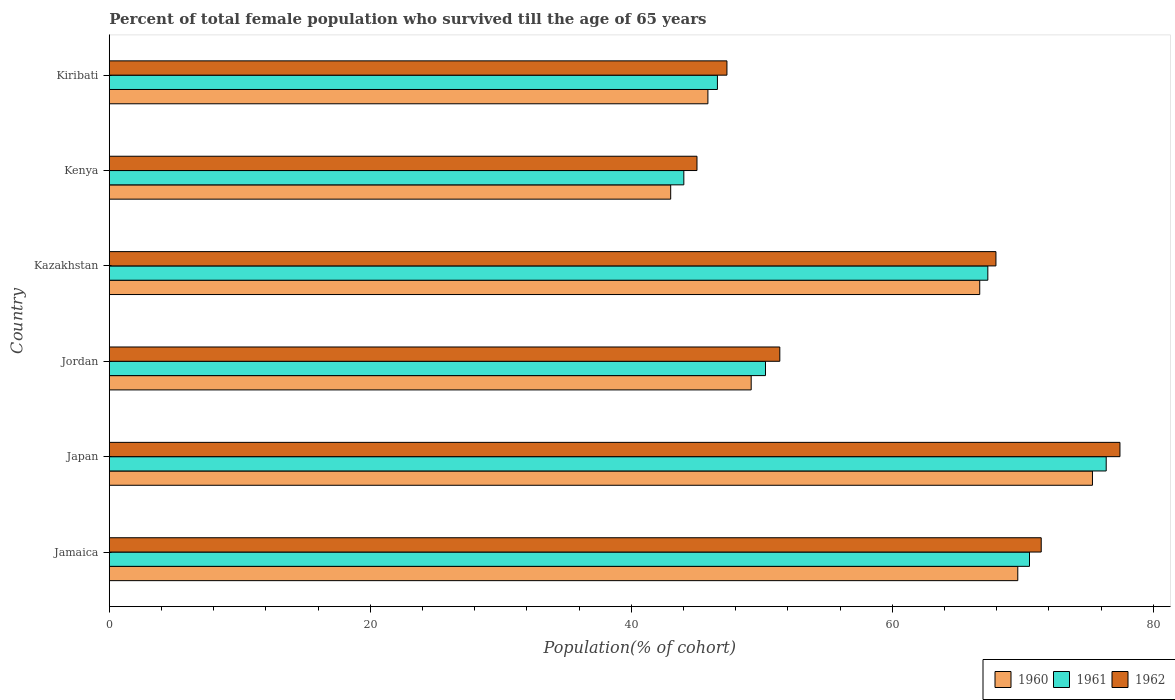How many different coloured bars are there?
Provide a short and direct response. 3. Are the number of bars per tick equal to the number of legend labels?
Your answer should be very brief. Yes. How many bars are there on the 2nd tick from the bottom?
Make the answer very short. 3. What is the percentage of total female population who survived till the age of 65 years in 1961 in Kazakhstan?
Provide a short and direct response. 67.33. Across all countries, what is the maximum percentage of total female population who survived till the age of 65 years in 1961?
Give a very brief answer. 76.4. Across all countries, what is the minimum percentage of total female population who survived till the age of 65 years in 1962?
Your response must be concise. 45.04. In which country was the percentage of total female population who survived till the age of 65 years in 1962 minimum?
Your response must be concise. Kenya. What is the total percentage of total female population who survived till the age of 65 years in 1962 in the graph?
Your answer should be very brief. 360.58. What is the difference between the percentage of total female population who survived till the age of 65 years in 1962 in Jordan and that in Kiribati?
Offer a very short reply. 4.05. What is the difference between the percentage of total female population who survived till the age of 65 years in 1960 in Japan and the percentage of total female population who survived till the age of 65 years in 1961 in Jamaica?
Your response must be concise. 4.82. What is the average percentage of total female population who survived till the age of 65 years in 1961 per country?
Offer a terse response. 59.2. What is the difference between the percentage of total female population who survived till the age of 65 years in 1961 and percentage of total female population who survived till the age of 65 years in 1960 in Japan?
Your response must be concise. 1.05. In how many countries, is the percentage of total female population who survived till the age of 65 years in 1962 greater than 24 %?
Keep it short and to the point. 6. What is the ratio of the percentage of total female population who survived till the age of 65 years in 1962 in Jordan to that in Kiribati?
Keep it short and to the point. 1.09. Is the difference between the percentage of total female population who survived till the age of 65 years in 1961 in Japan and Kiribati greater than the difference between the percentage of total female population who survived till the age of 65 years in 1960 in Japan and Kiribati?
Your answer should be compact. Yes. What is the difference between the highest and the second highest percentage of total female population who survived till the age of 65 years in 1961?
Your response must be concise. 5.88. What is the difference between the highest and the lowest percentage of total female population who survived till the age of 65 years in 1960?
Ensure brevity in your answer.  32.32. Is the sum of the percentage of total female population who survived till the age of 65 years in 1962 in Japan and Kenya greater than the maximum percentage of total female population who survived till the age of 65 years in 1961 across all countries?
Give a very brief answer. Yes. What does the 1st bar from the top in Kazakhstan represents?
Make the answer very short. 1962. What does the 3rd bar from the bottom in Kenya represents?
Offer a terse response. 1962. Is it the case that in every country, the sum of the percentage of total female population who survived till the age of 65 years in 1960 and percentage of total female population who survived till the age of 65 years in 1962 is greater than the percentage of total female population who survived till the age of 65 years in 1961?
Your answer should be compact. Yes. Are all the bars in the graph horizontal?
Offer a very short reply. Yes. How many countries are there in the graph?
Offer a very short reply. 6. Are the values on the major ticks of X-axis written in scientific E-notation?
Provide a succinct answer. No. Does the graph contain grids?
Your answer should be very brief. No. Where does the legend appear in the graph?
Make the answer very short. Bottom right. How many legend labels are there?
Keep it short and to the point. 3. How are the legend labels stacked?
Provide a short and direct response. Horizontal. What is the title of the graph?
Give a very brief answer. Percent of total female population who survived till the age of 65 years. What is the label or title of the X-axis?
Your response must be concise. Population(% of cohort). What is the Population(% of cohort) of 1960 in Jamaica?
Make the answer very short. 69.62. What is the Population(% of cohort) of 1961 in Jamaica?
Offer a terse response. 70.52. What is the Population(% of cohort) in 1962 in Jamaica?
Your answer should be very brief. 71.42. What is the Population(% of cohort) in 1960 in Japan?
Provide a short and direct response. 75.35. What is the Population(% of cohort) in 1961 in Japan?
Your answer should be compact. 76.4. What is the Population(% of cohort) in 1962 in Japan?
Your answer should be very brief. 77.45. What is the Population(% of cohort) in 1960 in Jordan?
Make the answer very short. 49.19. What is the Population(% of cohort) in 1961 in Jordan?
Your response must be concise. 50.29. What is the Population(% of cohort) of 1962 in Jordan?
Your answer should be compact. 51.39. What is the Population(% of cohort) in 1960 in Kazakhstan?
Your response must be concise. 66.71. What is the Population(% of cohort) of 1961 in Kazakhstan?
Offer a very short reply. 67.33. What is the Population(% of cohort) of 1962 in Kazakhstan?
Give a very brief answer. 67.95. What is the Population(% of cohort) of 1960 in Kenya?
Provide a succinct answer. 43.02. What is the Population(% of cohort) of 1961 in Kenya?
Ensure brevity in your answer.  44.03. What is the Population(% of cohort) in 1962 in Kenya?
Your answer should be compact. 45.04. What is the Population(% of cohort) of 1960 in Kiribati?
Your response must be concise. 45.88. What is the Population(% of cohort) in 1961 in Kiribati?
Provide a succinct answer. 46.6. What is the Population(% of cohort) of 1962 in Kiribati?
Your answer should be very brief. 47.33. Across all countries, what is the maximum Population(% of cohort) of 1960?
Ensure brevity in your answer.  75.35. Across all countries, what is the maximum Population(% of cohort) of 1961?
Your answer should be compact. 76.4. Across all countries, what is the maximum Population(% of cohort) in 1962?
Your response must be concise. 77.45. Across all countries, what is the minimum Population(% of cohort) in 1960?
Your answer should be very brief. 43.02. Across all countries, what is the minimum Population(% of cohort) of 1961?
Give a very brief answer. 44.03. Across all countries, what is the minimum Population(% of cohort) of 1962?
Provide a short and direct response. 45.04. What is the total Population(% of cohort) of 1960 in the graph?
Provide a succinct answer. 349.77. What is the total Population(% of cohort) in 1961 in the graph?
Provide a succinct answer. 355.17. What is the total Population(% of cohort) of 1962 in the graph?
Keep it short and to the point. 360.58. What is the difference between the Population(% of cohort) of 1960 in Jamaica and that in Japan?
Offer a terse response. -5.72. What is the difference between the Population(% of cohort) in 1961 in Jamaica and that in Japan?
Give a very brief answer. -5.88. What is the difference between the Population(% of cohort) in 1962 in Jamaica and that in Japan?
Your answer should be very brief. -6.03. What is the difference between the Population(% of cohort) in 1960 in Jamaica and that in Jordan?
Ensure brevity in your answer.  20.43. What is the difference between the Population(% of cohort) in 1961 in Jamaica and that in Jordan?
Offer a terse response. 20.23. What is the difference between the Population(% of cohort) in 1962 in Jamaica and that in Jordan?
Your answer should be compact. 20.03. What is the difference between the Population(% of cohort) in 1960 in Jamaica and that in Kazakhstan?
Your answer should be very brief. 2.92. What is the difference between the Population(% of cohort) in 1961 in Jamaica and that in Kazakhstan?
Offer a terse response. 3.19. What is the difference between the Population(% of cohort) of 1962 in Jamaica and that in Kazakhstan?
Offer a terse response. 3.47. What is the difference between the Population(% of cohort) of 1960 in Jamaica and that in Kenya?
Your answer should be compact. 26.6. What is the difference between the Population(% of cohort) in 1961 in Jamaica and that in Kenya?
Your answer should be compact. 26.49. What is the difference between the Population(% of cohort) of 1962 in Jamaica and that in Kenya?
Your answer should be very brief. 26.38. What is the difference between the Population(% of cohort) of 1960 in Jamaica and that in Kiribati?
Keep it short and to the point. 23.75. What is the difference between the Population(% of cohort) of 1961 in Jamaica and that in Kiribati?
Keep it short and to the point. 23.92. What is the difference between the Population(% of cohort) in 1962 in Jamaica and that in Kiribati?
Your answer should be very brief. 24.08. What is the difference between the Population(% of cohort) in 1960 in Japan and that in Jordan?
Provide a short and direct response. 26.15. What is the difference between the Population(% of cohort) of 1961 in Japan and that in Jordan?
Your answer should be compact. 26.11. What is the difference between the Population(% of cohort) in 1962 in Japan and that in Jordan?
Your response must be concise. 26.07. What is the difference between the Population(% of cohort) of 1960 in Japan and that in Kazakhstan?
Your answer should be very brief. 8.64. What is the difference between the Population(% of cohort) in 1961 in Japan and that in Kazakhstan?
Your answer should be compact. 9.07. What is the difference between the Population(% of cohort) in 1962 in Japan and that in Kazakhstan?
Provide a succinct answer. 9.5. What is the difference between the Population(% of cohort) of 1960 in Japan and that in Kenya?
Your answer should be compact. 32.32. What is the difference between the Population(% of cohort) in 1961 in Japan and that in Kenya?
Your answer should be compact. 32.37. What is the difference between the Population(% of cohort) of 1962 in Japan and that in Kenya?
Your response must be concise. 32.41. What is the difference between the Population(% of cohort) of 1960 in Japan and that in Kiribati?
Your answer should be compact. 29.47. What is the difference between the Population(% of cohort) of 1961 in Japan and that in Kiribati?
Your answer should be very brief. 29.79. What is the difference between the Population(% of cohort) of 1962 in Japan and that in Kiribati?
Make the answer very short. 30.12. What is the difference between the Population(% of cohort) of 1960 in Jordan and that in Kazakhstan?
Keep it short and to the point. -17.51. What is the difference between the Population(% of cohort) of 1961 in Jordan and that in Kazakhstan?
Make the answer very short. -17.04. What is the difference between the Population(% of cohort) of 1962 in Jordan and that in Kazakhstan?
Provide a succinct answer. -16.56. What is the difference between the Population(% of cohort) in 1960 in Jordan and that in Kenya?
Keep it short and to the point. 6.17. What is the difference between the Population(% of cohort) in 1961 in Jordan and that in Kenya?
Your answer should be compact. 6.26. What is the difference between the Population(% of cohort) in 1962 in Jordan and that in Kenya?
Your answer should be compact. 6.35. What is the difference between the Population(% of cohort) in 1960 in Jordan and that in Kiribati?
Make the answer very short. 3.32. What is the difference between the Population(% of cohort) of 1961 in Jordan and that in Kiribati?
Provide a succinct answer. 3.68. What is the difference between the Population(% of cohort) in 1962 in Jordan and that in Kiribati?
Your response must be concise. 4.05. What is the difference between the Population(% of cohort) of 1960 in Kazakhstan and that in Kenya?
Provide a succinct answer. 23.68. What is the difference between the Population(% of cohort) of 1961 in Kazakhstan and that in Kenya?
Your answer should be very brief. 23.3. What is the difference between the Population(% of cohort) in 1962 in Kazakhstan and that in Kenya?
Make the answer very short. 22.91. What is the difference between the Population(% of cohort) in 1960 in Kazakhstan and that in Kiribati?
Ensure brevity in your answer.  20.83. What is the difference between the Population(% of cohort) in 1961 in Kazakhstan and that in Kiribati?
Your answer should be very brief. 20.72. What is the difference between the Population(% of cohort) of 1962 in Kazakhstan and that in Kiribati?
Your response must be concise. 20.61. What is the difference between the Population(% of cohort) in 1960 in Kenya and that in Kiribati?
Offer a terse response. -2.85. What is the difference between the Population(% of cohort) of 1961 in Kenya and that in Kiribati?
Offer a very short reply. -2.57. What is the difference between the Population(% of cohort) in 1962 in Kenya and that in Kiribati?
Provide a succinct answer. -2.3. What is the difference between the Population(% of cohort) in 1960 in Jamaica and the Population(% of cohort) in 1961 in Japan?
Give a very brief answer. -6.78. What is the difference between the Population(% of cohort) of 1960 in Jamaica and the Population(% of cohort) of 1962 in Japan?
Offer a terse response. -7.83. What is the difference between the Population(% of cohort) in 1961 in Jamaica and the Population(% of cohort) in 1962 in Japan?
Ensure brevity in your answer.  -6.93. What is the difference between the Population(% of cohort) of 1960 in Jamaica and the Population(% of cohort) of 1961 in Jordan?
Provide a short and direct response. 19.33. What is the difference between the Population(% of cohort) in 1960 in Jamaica and the Population(% of cohort) in 1962 in Jordan?
Provide a short and direct response. 18.24. What is the difference between the Population(% of cohort) in 1961 in Jamaica and the Population(% of cohort) in 1962 in Jordan?
Make the answer very short. 19.13. What is the difference between the Population(% of cohort) of 1960 in Jamaica and the Population(% of cohort) of 1961 in Kazakhstan?
Offer a very short reply. 2.3. What is the difference between the Population(% of cohort) in 1960 in Jamaica and the Population(% of cohort) in 1962 in Kazakhstan?
Ensure brevity in your answer.  1.67. What is the difference between the Population(% of cohort) of 1961 in Jamaica and the Population(% of cohort) of 1962 in Kazakhstan?
Provide a short and direct response. 2.57. What is the difference between the Population(% of cohort) of 1960 in Jamaica and the Population(% of cohort) of 1961 in Kenya?
Ensure brevity in your answer.  25.59. What is the difference between the Population(% of cohort) in 1960 in Jamaica and the Population(% of cohort) in 1962 in Kenya?
Your response must be concise. 24.58. What is the difference between the Population(% of cohort) of 1961 in Jamaica and the Population(% of cohort) of 1962 in Kenya?
Offer a terse response. 25.48. What is the difference between the Population(% of cohort) of 1960 in Jamaica and the Population(% of cohort) of 1961 in Kiribati?
Ensure brevity in your answer.  23.02. What is the difference between the Population(% of cohort) in 1960 in Jamaica and the Population(% of cohort) in 1962 in Kiribati?
Give a very brief answer. 22.29. What is the difference between the Population(% of cohort) in 1961 in Jamaica and the Population(% of cohort) in 1962 in Kiribati?
Give a very brief answer. 23.19. What is the difference between the Population(% of cohort) of 1960 in Japan and the Population(% of cohort) of 1961 in Jordan?
Your answer should be compact. 25.06. What is the difference between the Population(% of cohort) in 1960 in Japan and the Population(% of cohort) in 1962 in Jordan?
Offer a terse response. 23.96. What is the difference between the Population(% of cohort) in 1961 in Japan and the Population(% of cohort) in 1962 in Jordan?
Offer a terse response. 25.01. What is the difference between the Population(% of cohort) of 1960 in Japan and the Population(% of cohort) of 1961 in Kazakhstan?
Make the answer very short. 8.02. What is the difference between the Population(% of cohort) of 1960 in Japan and the Population(% of cohort) of 1962 in Kazakhstan?
Make the answer very short. 7.4. What is the difference between the Population(% of cohort) of 1961 in Japan and the Population(% of cohort) of 1962 in Kazakhstan?
Offer a very short reply. 8.45. What is the difference between the Population(% of cohort) of 1960 in Japan and the Population(% of cohort) of 1961 in Kenya?
Offer a terse response. 31.31. What is the difference between the Population(% of cohort) of 1960 in Japan and the Population(% of cohort) of 1962 in Kenya?
Give a very brief answer. 30.31. What is the difference between the Population(% of cohort) in 1961 in Japan and the Population(% of cohort) in 1962 in Kenya?
Offer a terse response. 31.36. What is the difference between the Population(% of cohort) in 1960 in Japan and the Population(% of cohort) in 1961 in Kiribati?
Provide a succinct answer. 28.74. What is the difference between the Population(% of cohort) of 1960 in Japan and the Population(% of cohort) of 1962 in Kiribati?
Your response must be concise. 28.01. What is the difference between the Population(% of cohort) of 1961 in Japan and the Population(% of cohort) of 1962 in Kiribati?
Your response must be concise. 29.07. What is the difference between the Population(% of cohort) in 1960 in Jordan and the Population(% of cohort) in 1961 in Kazakhstan?
Offer a very short reply. -18.14. What is the difference between the Population(% of cohort) in 1960 in Jordan and the Population(% of cohort) in 1962 in Kazakhstan?
Give a very brief answer. -18.76. What is the difference between the Population(% of cohort) of 1961 in Jordan and the Population(% of cohort) of 1962 in Kazakhstan?
Offer a very short reply. -17.66. What is the difference between the Population(% of cohort) in 1960 in Jordan and the Population(% of cohort) in 1961 in Kenya?
Make the answer very short. 5.16. What is the difference between the Population(% of cohort) in 1960 in Jordan and the Population(% of cohort) in 1962 in Kenya?
Ensure brevity in your answer.  4.15. What is the difference between the Population(% of cohort) in 1961 in Jordan and the Population(% of cohort) in 1962 in Kenya?
Offer a very short reply. 5.25. What is the difference between the Population(% of cohort) in 1960 in Jordan and the Population(% of cohort) in 1961 in Kiribati?
Make the answer very short. 2.59. What is the difference between the Population(% of cohort) of 1960 in Jordan and the Population(% of cohort) of 1962 in Kiribati?
Offer a terse response. 1.86. What is the difference between the Population(% of cohort) in 1961 in Jordan and the Population(% of cohort) in 1962 in Kiribati?
Ensure brevity in your answer.  2.96. What is the difference between the Population(% of cohort) of 1960 in Kazakhstan and the Population(% of cohort) of 1961 in Kenya?
Your answer should be very brief. 22.68. What is the difference between the Population(% of cohort) in 1960 in Kazakhstan and the Population(% of cohort) in 1962 in Kenya?
Provide a succinct answer. 21.67. What is the difference between the Population(% of cohort) of 1961 in Kazakhstan and the Population(% of cohort) of 1962 in Kenya?
Give a very brief answer. 22.29. What is the difference between the Population(% of cohort) in 1960 in Kazakhstan and the Population(% of cohort) in 1961 in Kiribati?
Your answer should be very brief. 20.1. What is the difference between the Population(% of cohort) in 1960 in Kazakhstan and the Population(% of cohort) in 1962 in Kiribati?
Make the answer very short. 19.37. What is the difference between the Population(% of cohort) of 1961 in Kazakhstan and the Population(% of cohort) of 1962 in Kiribati?
Ensure brevity in your answer.  19.99. What is the difference between the Population(% of cohort) of 1960 in Kenya and the Population(% of cohort) of 1961 in Kiribati?
Your answer should be very brief. -3.58. What is the difference between the Population(% of cohort) in 1960 in Kenya and the Population(% of cohort) in 1962 in Kiribati?
Provide a short and direct response. -4.31. What is the difference between the Population(% of cohort) of 1961 in Kenya and the Population(% of cohort) of 1962 in Kiribati?
Provide a short and direct response. -3.3. What is the average Population(% of cohort) of 1960 per country?
Your answer should be compact. 58.29. What is the average Population(% of cohort) of 1961 per country?
Your answer should be compact. 59.2. What is the average Population(% of cohort) of 1962 per country?
Provide a short and direct response. 60.1. What is the difference between the Population(% of cohort) in 1960 and Population(% of cohort) in 1961 in Jamaica?
Provide a short and direct response. -0.9. What is the difference between the Population(% of cohort) in 1960 and Population(% of cohort) in 1962 in Jamaica?
Your answer should be very brief. -1.8. What is the difference between the Population(% of cohort) of 1961 and Population(% of cohort) of 1962 in Jamaica?
Your answer should be very brief. -0.9. What is the difference between the Population(% of cohort) in 1960 and Population(% of cohort) in 1961 in Japan?
Your answer should be compact. -1.05. What is the difference between the Population(% of cohort) of 1960 and Population(% of cohort) of 1962 in Japan?
Provide a succinct answer. -2.11. What is the difference between the Population(% of cohort) of 1961 and Population(% of cohort) of 1962 in Japan?
Offer a very short reply. -1.05. What is the difference between the Population(% of cohort) of 1960 and Population(% of cohort) of 1961 in Jordan?
Your response must be concise. -1.1. What is the difference between the Population(% of cohort) in 1960 and Population(% of cohort) in 1962 in Jordan?
Provide a succinct answer. -2.19. What is the difference between the Population(% of cohort) of 1961 and Population(% of cohort) of 1962 in Jordan?
Offer a terse response. -1.1. What is the difference between the Population(% of cohort) in 1960 and Population(% of cohort) in 1961 in Kazakhstan?
Your response must be concise. -0.62. What is the difference between the Population(% of cohort) in 1960 and Population(% of cohort) in 1962 in Kazakhstan?
Make the answer very short. -1.24. What is the difference between the Population(% of cohort) in 1961 and Population(% of cohort) in 1962 in Kazakhstan?
Ensure brevity in your answer.  -0.62. What is the difference between the Population(% of cohort) in 1960 and Population(% of cohort) in 1961 in Kenya?
Make the answer very short. -1.01. What is the difference between the Population(% of cohort) in 1960 and Population(% of cohort) in 1962 in Kenya?
Give a very brief answer. -2.02. What is the difference between the Population(% of cohort) in 1961 and Population(% of cohort) in 1962 in Kenya?
Make the answer very short. -1.01. What is the difference between the Population(% of cohort) in 1960 and Population(% of cohort) in 1961 in Kiribati?
Give a very brief answer. -0.73. What is the difference between the Population(% of cohort) in 1960 and Population(% of cohort) in 1962 in Kiribati?
Give a very brief answer. -1.46. What is the difference between the Population(% of cohort) of 1961 and Population(% of cohort) of 1962 in Kiribati?
Provide a short and direct response. -0.73. What is the ratio of the Population(% of cohort) of 1960 in Jamaica to that in Japan?
Make the answer very short. 0.92. What is the ratio of the Population(% of cohort) in 1962 in Jamaica to that in Japan?
Give a very brief answer. 0.92. What is the ratio of the Population(% of cohort) in 1960 in Jamaica to that in Jordan?
Your answer should be very brief. 1.42. What is the ratio of the Population(% of cohort) of 1961 in Jamaica to that in Jordan?
Ensure brevity in your answer.  1.4. What is the ratio of the Population(% of cohort) in 1962 in Jamaica to that in Jordan?
Offer a terse response. 1.39. What is the ratio of the Population(% of cohort) of 1960 in Jamaica to that in Kazakhstan?
Ensure brevity in your answer.  1.04. What is the ratio of the Population(% of cohort) of 1961 in Jamaica to that in Kazakhstan?
Ensure brevity in your answer.  1.05. What is the ratio of the Population(% of cohort) of 1962 in Jamaica to that in Kazakhstan?
Provide a short and direct response. 1.05. What is the ratio of the Population(% of cohort) of 1960 in Jamaica to that in Kenya?
Make the answer very short. 1.62. What is the ratio of the Population(% of cohort) of 1961 in Jamaica to that in Kenya?
Offer a very short reply. 1.6. What is the ratio of the Population(% of cohort) of 1962 in Jamaica to that in Kenya?
Provide a succinct answer. 1.59. What is the ratio of the Population(% of cohort) of 1960 in Jamaica to that in Kiribati?
Provide a succinct answer. 1.52. What is the ratio of the Population(% of cohort) of 1961 in Jamaica to that in Kiribati?
Provide a short and direct response. 1.51. What is the ratio of the Population(% of cohort) in 1962 in Jamaica to that in Kiribati?
Give a very brief answer. 1.51. What is the ratio of the Population(% of cohort) of 1960 in Japan to that in Jordan?
Provide a succinct answer. 1.53. What is the ratio of the Population(% of cohort) in 1961 in Japan to that in Jordan?
Make the answer very short. 1.52. What is the ratio of the Population(% of cohort) of 1962 in Japan to that in Jordan?
Keep it short and to the point. 1.51. What is the ratio of the Population(% of cohort) in 1960 in Japan to that in Kazakhstan?
Offer a very short reply. 1.13. What is the ratio of the Population(% of cohort) of 1961 in Japan to that in Kazakhstan?
Your answer should be compact. 1.13. What is the ratio of the Population(% of cohort) in 1962 in Japan to that in Kazakhstan?
Give a very brief answer. 1.14. What is the ratio of the Population(% of cohort) of 1960 in Japan to that in Kenya?
Your answer should be very brief. 1.75. What is the ratio of the Population(% of cohort) in 1961 in Japan to that in Kenya?
Ensure brevity in your answer.  1.74. What is the ratio of the Population(% of cohort) of 1962 in Japan to that in Kenya?
Provide a succinct answer. 1.72. What is the ratio of the Population(% of cohort) in 1960 in Japan to that in Kiribati?
Ensure brevity in your answer.  1.64. What is the ratio of the Population(% of cohort) in 1961 in Japan to that in Kiribati?
Provide a short and direct response. 1.64. What is the ratio of the Population(% of cohort) of 1962 in Japan to that in Kiribati?
Give a very brief answer. 1.64. What is the ratio of the Population(% of cohort) of 1960 in Jordan to that in Kazakhstan?
Give a very brief answer. 0.74. What is the ratio of the Population(% of cohort) in 1961 in Jordan to that in Kazakhstan?
Offer a terse response. 0.75. What is the ratio of the Population(% of cohort) in 1962 in Jordan to that in Kazakhstan?
Keep it short and to the point. 0.76. What is the ratio of the Population(% of cohort) in 1960 in Jordan to that in Kenya?
Provide a succinct answer. 1.14. What is the ratio of the Population(% of cohort) of 1961 in Jordan to that in Kenya?
Offer a terse response. 1.14. What is the ratio of the Population(% of cohort) of 1962 in Jordan to that in Kenya?
Provide a short and direct response. 1.14. What is the ratio of the Population(% of cohort) in 1960 in Jordan to that in Kiribati?
Offer a terse response. 1.07. What is the ratio of the Population(% of cohort) of 1961 in Jordan to that in Kiribati?
Provide a succinct answer. 1.08. What is the ratio of the Population(% of cohort) of 1962 in Jordan to that in Kiribati?
Ensure brevity in your answer.  1.09. What is the ratio of the Population(% of cohort) in 1960 in Kazakhstan to that in Kenya?
Provide a succinct answer. 1.55. What is the ratio of the Population(% of cohort) of 1961 in Kazakhstan to that in Kenya?
Your answer should be compact. 1.53. What is the ratio of the Population(% of cohort) in 1962 in Kazakhstan to that in Kenya?
Give a very brief answer. 1.51. What is the ratio of the Population(% of cohort) in 1960 in Kazakhstan to that in Kiribati?
Your answer should be compact. 1.45. What is the ratio of the Population(% of cohort) in 1961 in Kazakhstan to that in Kiribati?
Ensure brevity in your answer.  1.44. What is the ratio of the Population(% of cohort) in 1962 in Kazakhstan to that in Kiribati?
Your response must be concise. 1.44. What is the ratio of the Population(% of cohort) in 1960 in Kenya to that in Kiribati?
Give a very brief answer. 0.94. What is the ratio of the Population(% of cohort) in 1961 in Kenya to that in Kiribati?
Provide a succinct answer. 0.94. What is the ratio of the Population(% of cohort) in 1962 in Kenya to that in Kiribati?
Your response must be concise. 0.95. What is the difference between the highest and the second highest Population(% of cohort) in 1960?
Give a very brief answer. 5.72. What is the difference between the highest and the second highest Population(% of cohort) in 1961?
Ensure brevity in your answer.  5.88. What is the difference between the highest and the second highest Population(% of cohort) of 1962?
Keep it short and to the point. 6.03. What is the difference between the highest and the lowest Population(% of cohort) in 1960?
Offer a very short reply. 32.32. What is the difference between the highest and the lowest Population(% of cohort) in 1961?
Make the answer very short. 32.37. What is the difference between the highest and the lowest Population(% of cohort) in 1962?
Give a very brief answer. 32.41. 